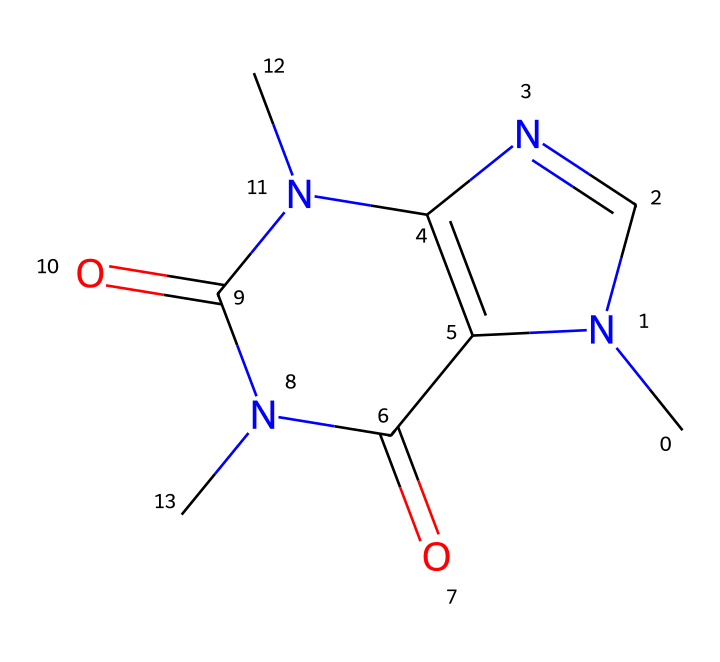What is the total number of nitrogen atoms in caffeine? Looking at the provided SMILES representation, we see the presence of three nitrogen (N) symbols. This indicates that there are three nitrogen atoms in the caffeine structure.
Answer: three How many carbon atoms are in the chemical structure of caffeine? By analyzing the SMILES, we can count the carbon (C) symbols present, which total to eight. Thus, there are eight carbon atoms in caffeine.
Answer: eight What functional groups are present in caffeine? The structure of caffeine contains carbonyl groups (C=O) and nitrogen atoms, indicating the presence of amide or imine functional groups.
Answer: amide, imine Which atoms are responsible for caffeine's basic nature? The nitrogen atoms in the structure act as bases due to their ability to donate a lone pair of electrons, contributing to caffeine's basic properties.
Answer: nitrogen What kind of chemical is caffeine classified as? Considering its structure and characteristics, caffeine falls under the category of alkaloids, specifically a methylxanthine analogue due to its nitrogen and carbon structure.
Answer: alkaloid How many rings are in the caffeine molecule? Upon examining the structure, we can identify that caffeine contains two fused rings which is typical for xanthine derivatives.
Answer: two What type of bonding is present between carbon and nitrogen in caffeine? The bonding between carbon and nitrogen in caffeine is primarily covalent, as these atoms share electrons to form stable bonds within the molecule.
Answer: covalent 